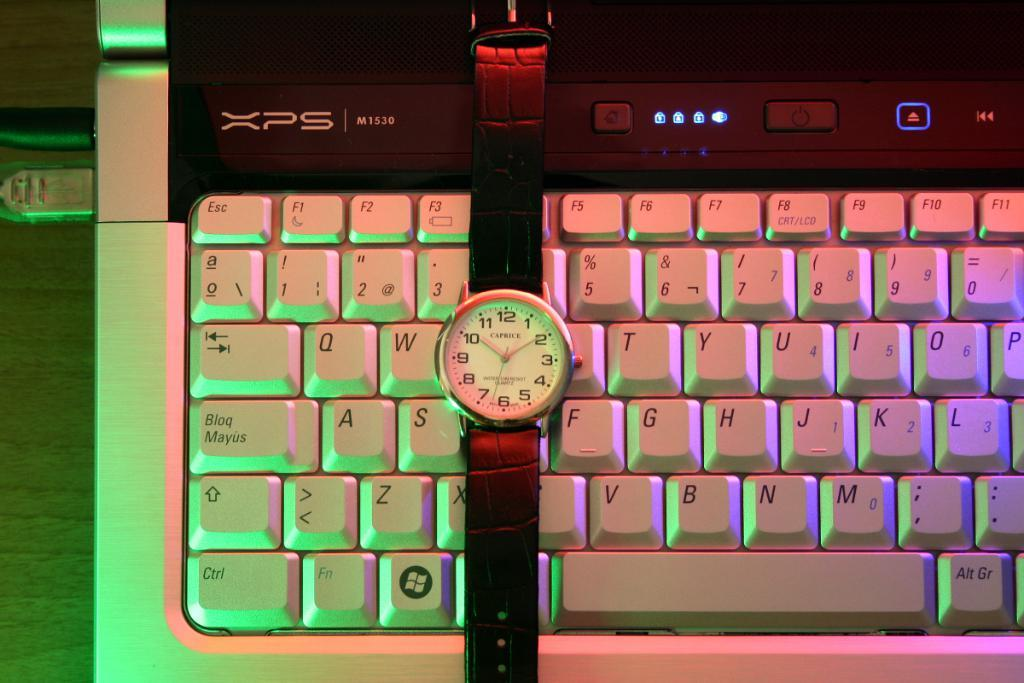Provide a one-sentence caption for the provided image. A Caprice watch sits on top of a computer keyboard. 